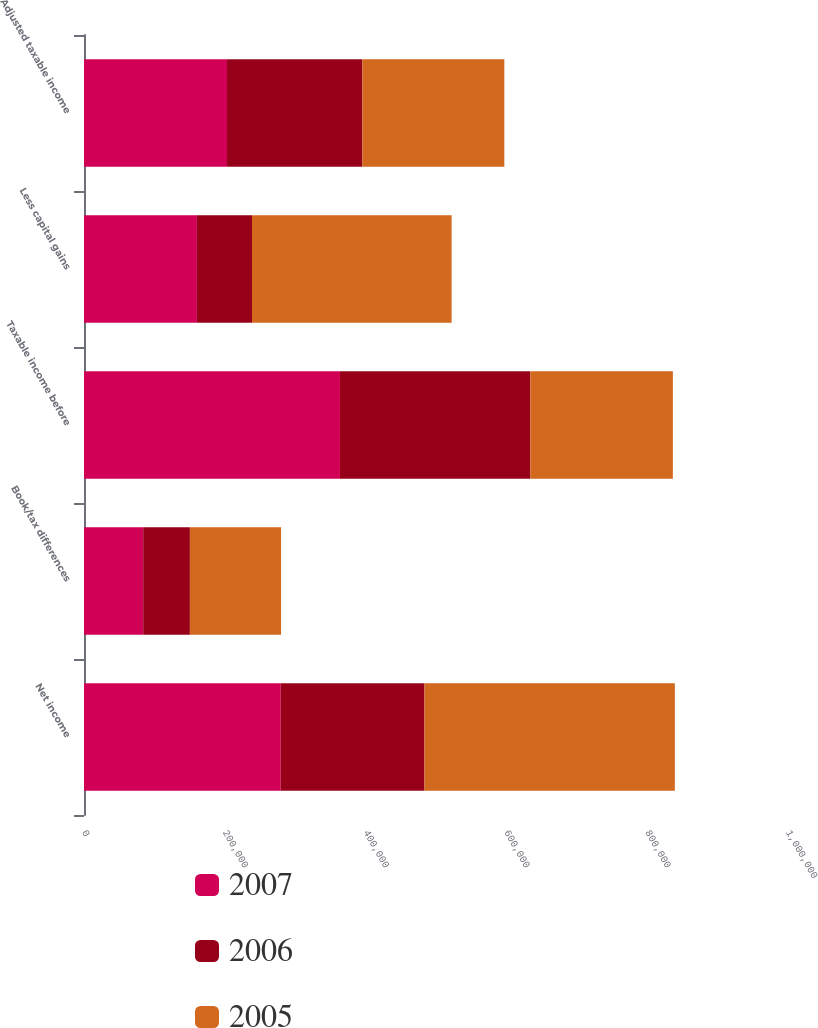Convert chart to OTSL. <chart><loc_0><loc_0><loc_500><loc_500><stacked_bar_chart><ecel><fcel>Net income<fcel>Book/tax differences<fcel>Taxable income before<fcel>Less capital gains<fcel>Adjusted taxable income<nl><fcel>2007<fcel>279467<fcel>84120<fcel>363587<fcel>160428<fcel>203159<nl><fcel>2006<fcel>204147<fcel>66303<fcel>270450<fcel>78246<fcel>192204<nl><fcel>2005<fcel>355662<fcel>129522<fcel>202422<fcel>283498<fcel>201686<nl></chart> 